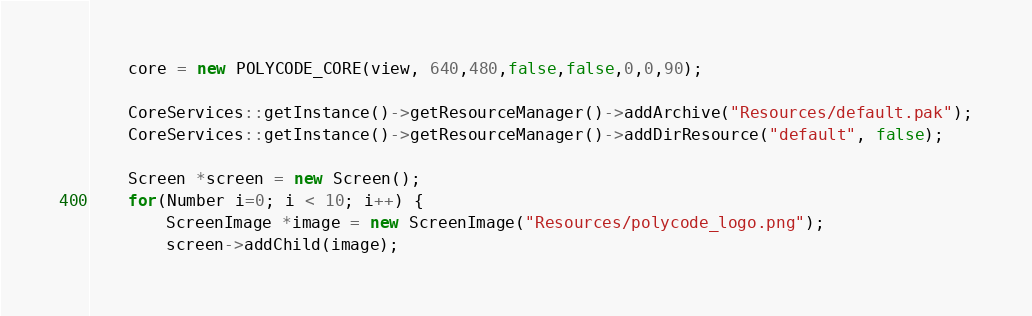Convert code to text. <code><loc_0><loc_0><loc_500><loc_500><_C++_>
	core = new POLYCODE_CORE(view, 640,480,false,false,0,0,90);

	CoreServices::getInstance()->getResourceManager()->addArchive("Resources/default.pak");
	CoreServices::getInstance()->getResourceManager()->addDirResource("default", false);

	Screen *screen = new Screen();			
	for(Number i=0; i < 10; i++) {
		ScreenImage *image = new ScreenImage("Resources/polycode_logo.png");
		screen->addChild(image);	</code> 